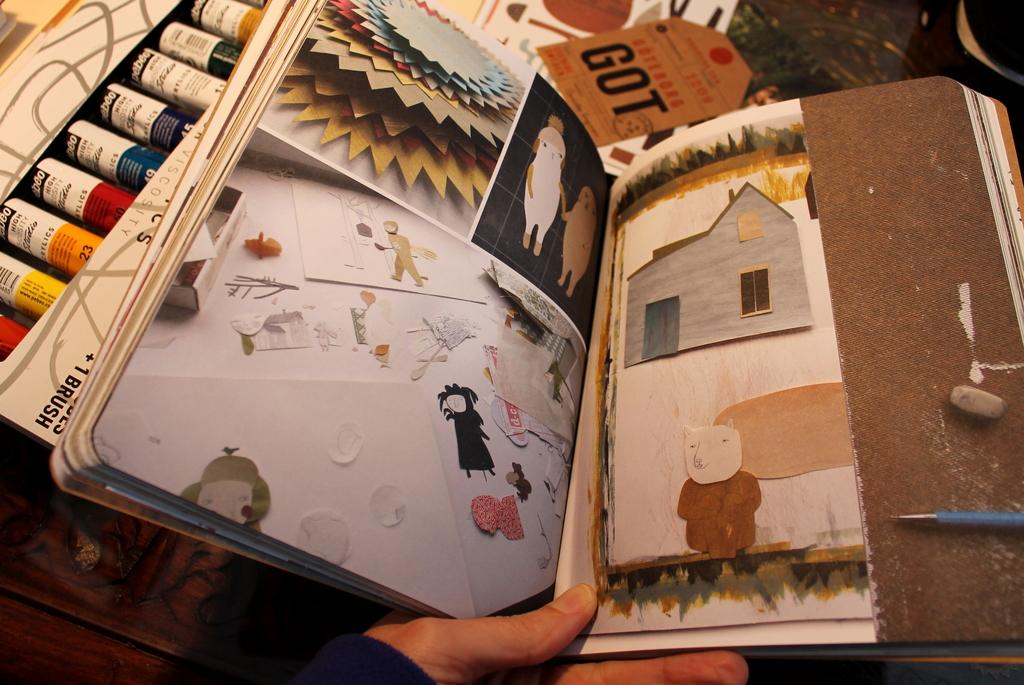<image>
Provide a brief description of the given image. A person is holding an open scrapbook by a paper tag that says GOT. 